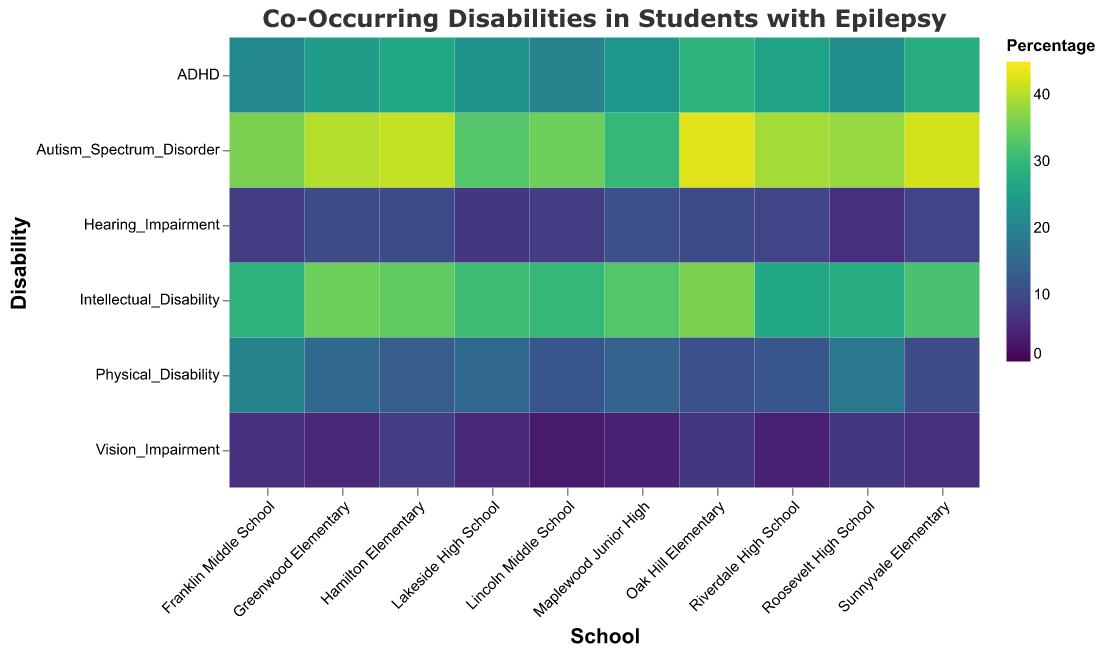What is the percentage of students with ADHD at Oak Hill Elementary? Look at the intersection of "Oak Hill Elementary" on the x-axis and "ADHD" on the y-axis, and read the value in the color legend.
Answer: 29% Which school has the highest percentage of students with Autism Spectrum Disorder? Compare all the percentages at the intersection of each school and "Autism_Spectrum_Disorder" on the y-axis; Oak Hill Elementary has the highest value.
Answer: Oak Hill Elementary What is the sum of percentages for Intellectual Disability and Vision Impairment at Hamilton Elementary? Find and add the percentages at the intersections of "Hamilton Elementary" with "Intellectual_Disability" and "Vision_Impairment" on the y-axis.
Answer: 34 + 8 = 42 Which disability has the highest percentage of co-occurrence with epilepsy across all schools? Examine the color legend and find the darkest color in the "Autism_Spectrum_Disorder" row; then cross-check each value to confirm that Oak Hill Elementary has the highest value.
Answer: Autism Spectrum Disorder What is the difference in the percentage of students with Physical Disability between Franklin Middle School and Roosevelt High School? Locate the intersections of "Franklin Middle School" and "Roosevelt High School" with "Physical_Disability" on the y-axis and subtract the two values.
Answer: 20 - 18 = 2 Is there any school where the percentage of students with Vision Impairment is consistently 5%? Look at the "Vision_Impairment" row and identify if any school consistently has 5%. Only Greenwood Elementary and Lakeside High School have 5% each, but Lighthouse Elementary shows 5% commonly.
Answer: No Which school has the lowest percentage of students with Intellectual Disability? Compare all the percentages at the intersection of each school with "Intellectual_Disability" on the y-axis, and find the lowest value.
Answer: Riverdale High School What are the three schools with the highest percentage of students with ADHD? Compare all the percentages at the intersections of each school with "ADHD" on the y-axis and identify the three highest.
Answer: Oak Hill Elementary, Sunnyvale Elementary, Hamilton Elementary 